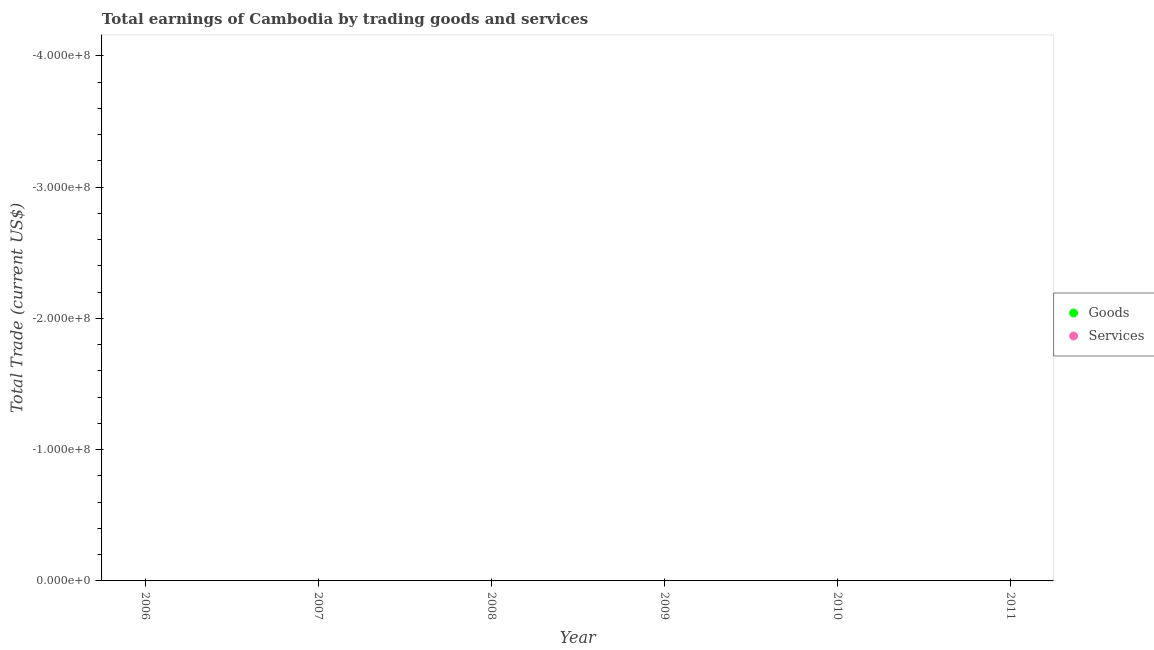How many different coloured dotlines are there?
Your response must be concise. 0. Is the number of dotlines equal to the number of legend labels?
Your answer should be compact. No. Across all years, what is the minimum amount earned by trading services?
Your answer should be compact. 0. What is the average amount earned by trading goods per year?
Offer a very short reply. 0. In how many years, is the amount earned by trading services greater than the average amount earned by trading services taken over all years?
Make the answer very short. 0. Is the amount earned by trading services strictly greater than the amount earned by trading goods over the years?
Keep it short and to the point. Yes. How many dotlines are there?
Ensure brevity in your answer.  0. How many years are there in the graph?
Make the answer very short. 6. Does the graph contain any zero values?
Give a very brief answer. Yes. Does the graph contain grids?
Your answer should be compact. No. How are the legend labels stacked?
Keep it short and to the point. Vertical. What is the title of the graph?
Your answer should be very brief. Total earnings of Cambodia by trading goods and services. Does "Transport services" appear as one of the legend labels in the graph?
Keep it short and to the point. No. What is the label or title of the Y-axis?
Provide a succinct answer. Total Trade (current US$). What is the Total Trade (current US$) of Goods in 2008?
Provide a succinct answer. 0. What is the Total Trade (current US$) in Goods in 2010?
Make the answer very short. 0. What is the Total Trade (current US$) of Goods in 2011?
Your answer should be very brief. 0. What is the Total Trade (current US$) of Services in 2011?
Give a very brief answer. 0. What is the total Total Trade (current US$) in Goods in the graph?
Your response must be concise. 0. What is the average Total Trade (current US$) of Goods per year?
Your answer should be very brief. 0. 